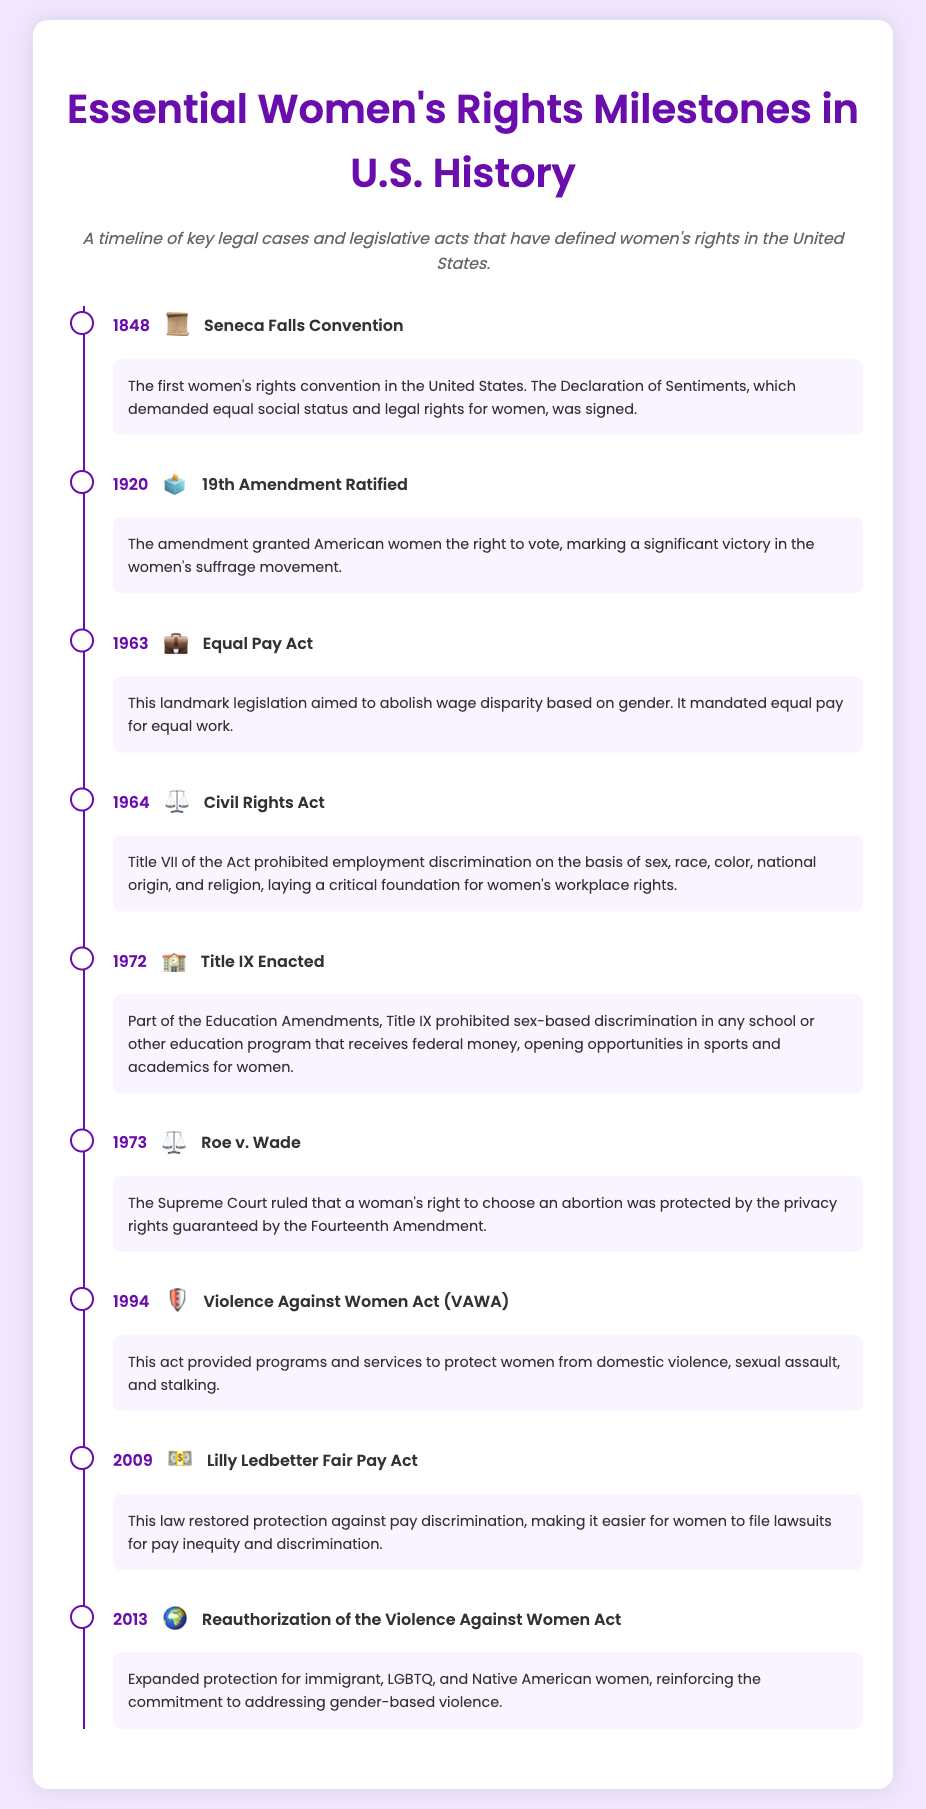What year was the Seneca Falls Convention held? The document states that the Seneca Falls Convention took place in 1848.
Answer: 1848 What was the significance of the 19th Amendment? According to the document, the 19th Amendment granted American women the right to vote.
Answer: Right to vote Which act aimed to abolish wage disparity based on gender? The document identifies the Equal Pay Act of 1963 as aimed at abolishing wage disparity based on gender.
Answer: Equal Pay Act How many milestones are listed in the timeline? By counting the milestones presented in the document, there are a total of nine milestones listed.
Answer: Nine What legislative act was enacted in 1972? The document specifically notes that Title IX was enacted in 1972.
Answer: Title IX What was a critical outcome of Roe v. Wade? The document explains that Roe v. Wade protected a woman's right to choose an abortion as per privacy rights.
Answer: Right to choose abortion Which law was reauthorized in 2013? The document mentions the reauthorization of the Violence Against Women Act in 2013.
Answer: Violence Against Women Act What icon represents the Lilly Ledbetter Fair Pay Act? The document uses the dollar sign icon to represent the Lilly Ledbetter Fair Pay Act.
Answer: Dollar sign What did the Violence Against Women Act of 1994 provide? The document states that VAWA provided programs and services to protect women from domestic violence, sexual assault, and stalking.
Answer: Protection from domestic violence 